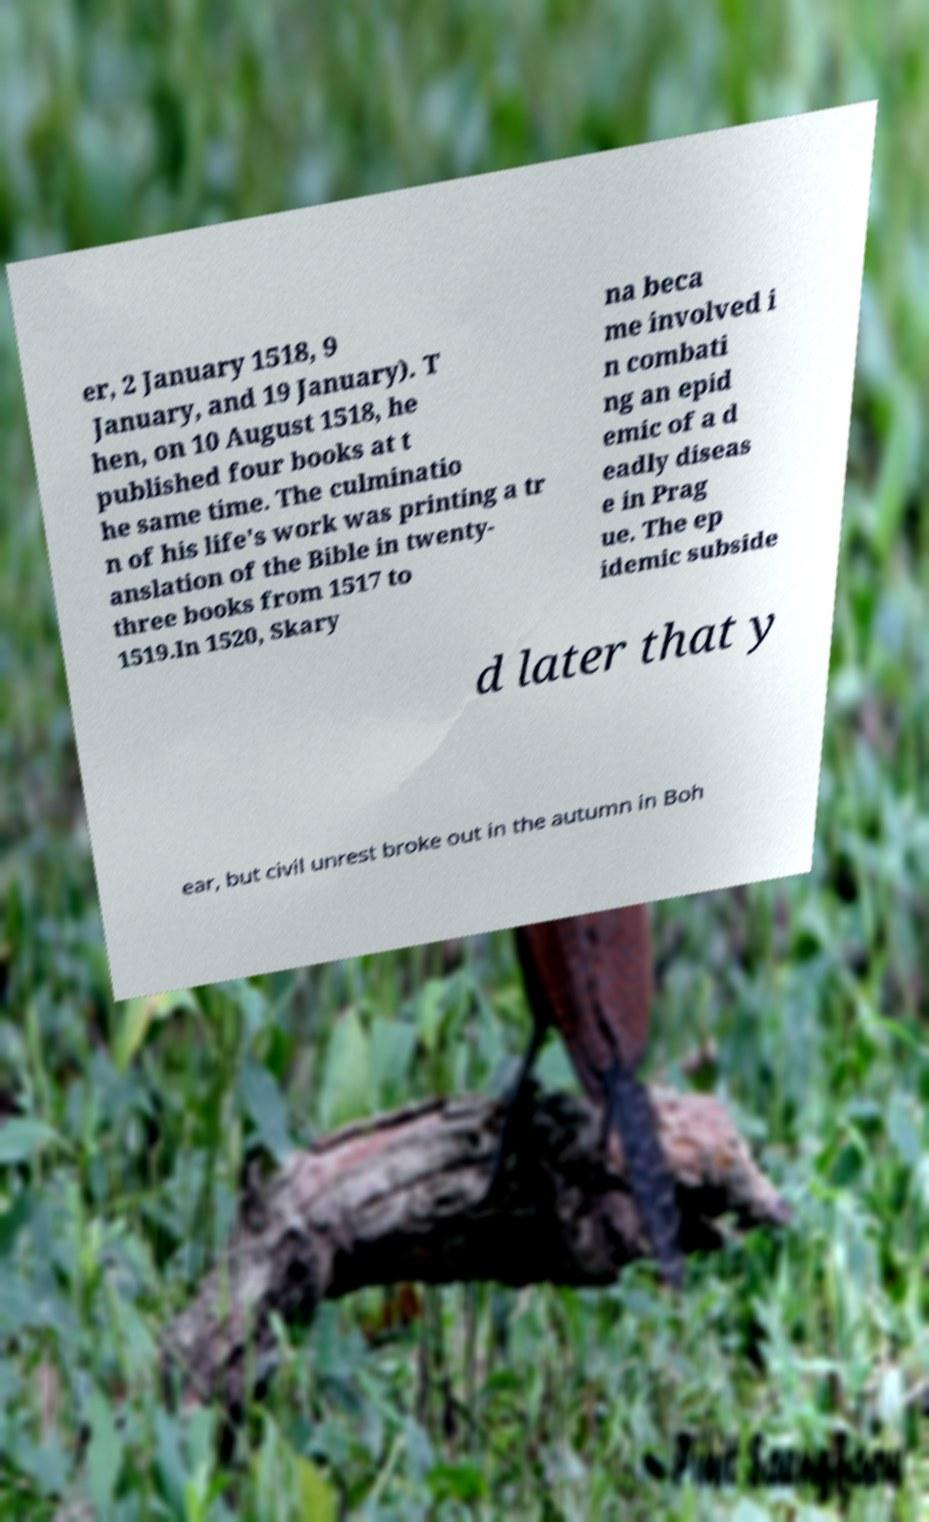For documentation purposes, I need the text within this image transcribed. Could you provide that? er, 2 January 1518, 9 January, and 19 January). T hen, on 10 August 1518, he published four books at t he same time. The culminatio n of his life's work was printing a tr anslation of the Bible in twenty- three books from 1517 to 1519.In 1520, Skary na beca me involved i n combati ng an epid emic of a d eadly diseas e in Prag ue. The ep idemic subside d later that y ear, but civil unrest broke out in the autumn in Boh 